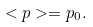Convert formula to latex. <formula><loc_0><loc_0><loc_500><loc_500>< p > = p _ { 0 } .</formula> 